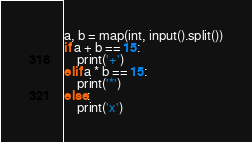Convert code to text. <code><loc_0><loc_0><loc_500><loc_500><_Python_>a, b = map(int, input().split())
if a + b == 15:
    print('+')
elif a * b == 15:
    print('*')
else:
    print('x')</code> 